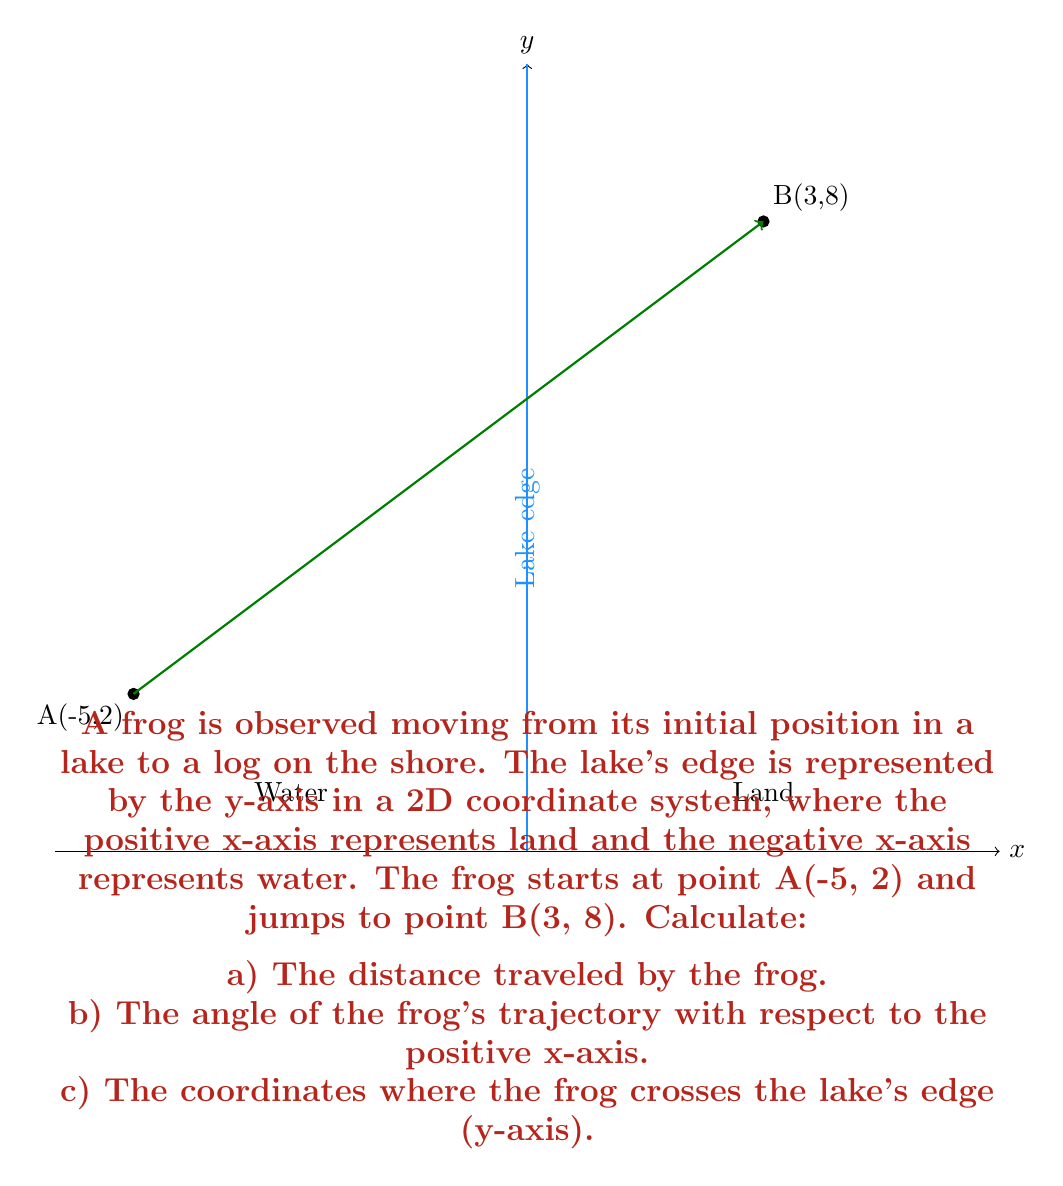Show me your answer to this math problem. Let's solve this problem step by step:

a) To calculate the distance traveled by the frog, we can use the distance formula between two points:

$$d = \sqrt{(x_2-x_1)^2 + (y_2-y_1)^2}$$

Substituting the coordinates:
$$d = \sqrt{(3-(-5))^2 + (8-2)^2} = \sqrt{8^2 + 6^2} = \sqrt{64 + 36} = \sqrt{100} = 10$$

b) To find the angle of the frog's trajectory with respect to the positive x-axis, we can use the arctangent function:

$$\theta = \arctan(\frac{y_2-y_1}{x_2-x_1})$$

Substituting the coordinates:
$$\theta = \arctan(\frac{8-2}{3-(-5)}) = \arctan(\frac{6}{8}) = \arctan(0.75) \approx 36.87°$$

c) To find where the frog crosses the lake's edge (y-axis), we need to find the equation of the line passing through points A and B, then solve for x = 0.

The slope of the line is:
$$m = \frac{y_2-y_1}{x_2-x_1} = \frac{8-2}{3-(-5)} = \frac{6}{8} = 0.75$$

Using point-slope form and point A:
$$y - 2 = 0.75(x - (-5))$$
$$y - 2 = 0.75x + 3.75$$
$$y = 0.75x + 5.75$$

To find where this line crosses the y-axis, set x = 0:
$$y = 0.75(0) + 5.75 = 5.75$$

Therefore, the frog crosses the lake's edge at the point (0, 5.75).
Answer: a) 10 units
b) 36.87°
c) (0, 5.75) 